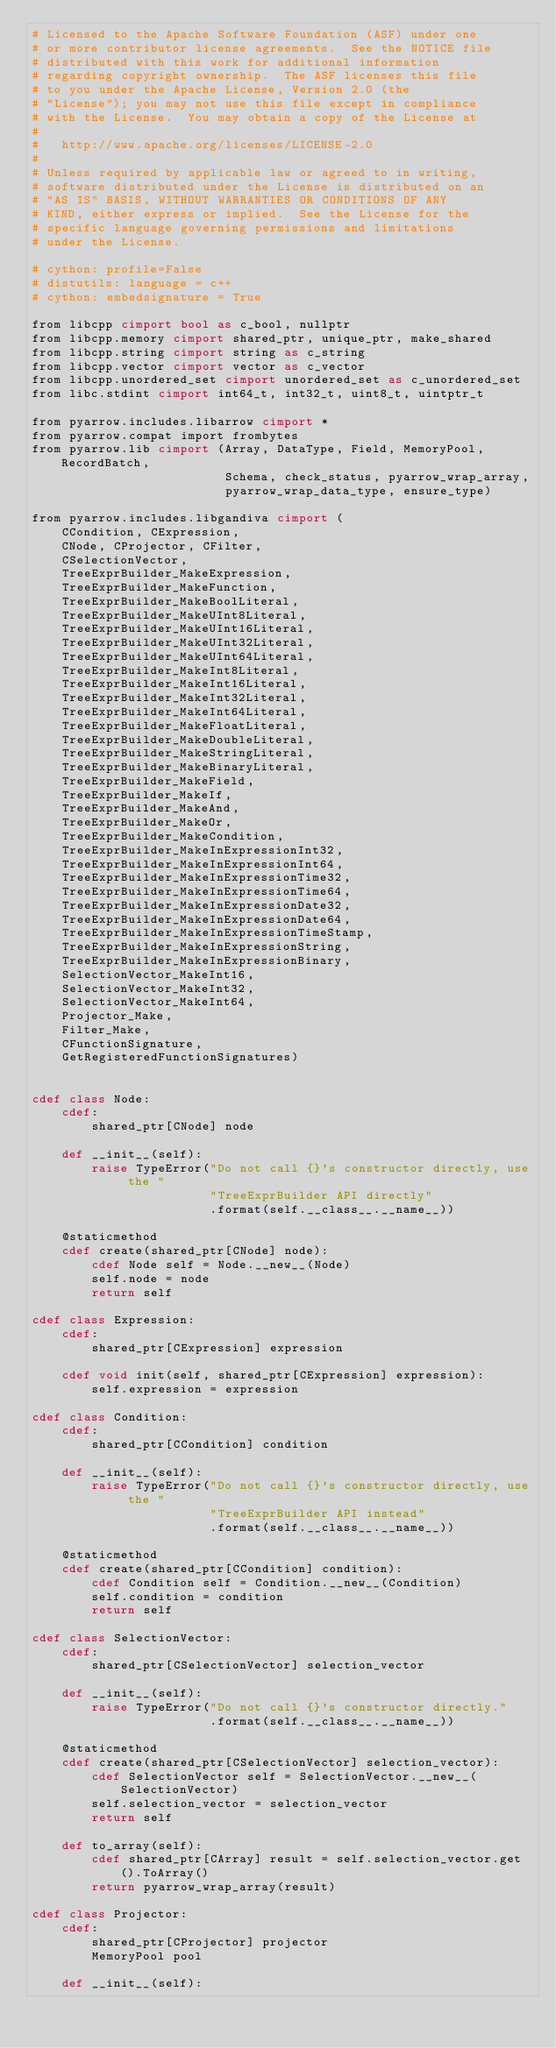Convert code to text. <code><loc_0><loc_0><loc_500><loc_500><_Cython_># Licensed to the Apache Software Foundation (ASF) under one
# or more contributor license agreements.  See the NOTICE file
# distributed with this work for additional information
# regarding copyright ownership.  The ASF licenses this file
# to you under the Apache License, Version 2.0 (the
# "License"); you may not use this file except in compliance
# with the License.  You may obtain a copy of the License at
#
#   http://www.apache.org/licenses/LICENSE-2.0
#
# Unless required by applicable law or agreed to in writing,
# software distributed under the License is distributed on an
# "AS IS" BASIS, WITHOUT WARRANTIES OR CONDITIONS OF ANY
# KIND, either express or implied.  See the License for the
# specific language governing permissions and limitations
# under the License.

# cython: profile=False
# distutils: language = c++
# cython: embedsignature = True

from libcpp cimport bool as c_bool, nullptr
from libcpp.memory cimport shared_ptr, unique_ptr, make_shared
from libcpp.string cimport string as c_string
from libcpp.vector cimport vector as c_vector
from libcpp.unordered_set cimport unordered_set as c_unordered_set
from libc.stdint cimport int64_t, int32_t, uint8_t, uintptr_t

from pyarrow.includes.libarrow cimport *
from pyarrow.compat import frombytes
from pyarrow.lib cimport (Array, DataType, Field, MemoryPool, RecordBatch,
                          Schema, check_status, pyarrow_wrap_array,
                          pyarrow_wrap_data_type, ensure_type)

from pyarrow.includes.libgandiva cimport (
    CCondition, CExpression,
    CNode, CProjector, CFilter,
    CSelectionVector,
    TreeExprBuilder_MakeExpression,
    TreeExprBuilder_MakeFunction,
    TreeExprBuilder_MakeBoolLiteral,
    TreeExprBuilder_MakeUInt8Literal,
    TreeExprBuilder_MakeUInt16Literal,
    TreeExprBuilder_MakeUInt32Literal,
    TreeExprBuilder_MakeUInt64Literal,
    TreeExprBuilder_MakeInt8Literal,
    TreeExprBuilder_MakeInt16Literal,
    TreeExprBuilder_MakeInt32Literal,
    TreeExprBuilder_MakeInt64Literal,
    TreeExprBuilder_MakeFloatLiteral,
    TreeExprBuilder_MakeDoubleLiteral,
    TreeExprBuilder_MakeStringLiteral,
    TreeExprBuilder_MakeBinaryLiteral,
    TreeExprBuilder_MakeField,
    TreeExprBuilder_MakeIf,
    TreeExprBuilder_MakeAnd,
    TreeExprBuilder_MakeOr,
    TreeExprBuilder_MakeCondition,
    TreeExprBuilder_MakeInExpressionInt32,
    TreeExprBuilder_MakeInExpressionInt64,
    TreeExprBuilder_MakeInExpressionTime32,
    TreeExprBuilder_MakeInExpressionTime64,
    TreeExprBuilder_MakeInExpressionDate32,
    TreeExprBuilder_MakeInExpressionDate64,
    TreeExprBuilder_MakeInExpressionTimeStamp,
    TreeExprBuilder_MakeInExpressionString,
    TreeExprBuilder_MakeInExpressionBinary,
    SelectionVector_MakeInt16,
    SelectionVector_MakeInt32,
    SelectionVector_MakeInt64,
    Projector_Make,
    Filter_Make,
    CFunctionSignature,
    GetRegisteredFunctionSignatures)


cdef class Node:
    cdef:
        shared_ptr[CNode] node

    def __init__(self):
        raise TypeError("Do not call {}'s constructor directly, use the "
                        "TreeExprBuilder API directly"
                        .format(self.__class__.__name__))

    @staticmethod
    cdef create(shared_ptr[CNode] node):
        cdef Node self = Node.__new__(Node)
        self.node = node
        return self

cdef class Expression:
    cdef:
        shared_ptr[CExpression] expression

    cdef void init(self, shared_ptr[CExpression] expression):
        self.expression = expression

cdef class Condition:
    cdef:
        shared_ptr[CCondition] condition

    def __init__(self):
        raise TypeError("Do not call {}'s constructor directly, use the "
                        "TreeExprBuilder API instead"
                        .format(self.__class__.__name__))

    @staticmethod
    cdef create(shared_ptr[CCondition] condition):
        cdef Condition self = Condition.__new__(Condition)
        self.condition = condition
        return self

cdef class SelectionVector:
    cdef:
        shared_ptr[CSelectionVector] selection_vector

    def __init__(self):
        raise TypeError("Do not call {}'s constructor directly."
                        .format(self.__class__.__name__))

    @staticmethod
    cdef create(shared_ptr[CSelectionVector] selection_vector):
        cdef SelectionVector self = SelectionVector.__new__(SelectionVector)
        self.selection_vector = selection_vector
        return self

    def to_array(self):
        cdef shared_ptr[CArray] result = self.selection_vector.get().ToArray()
        return pyarrow_wrap_array(result)

cdef class Projector:
    cdef:
        shared_ptr[CProjector] projector
        MemoryPool pool

    def __init__(self):</code> 